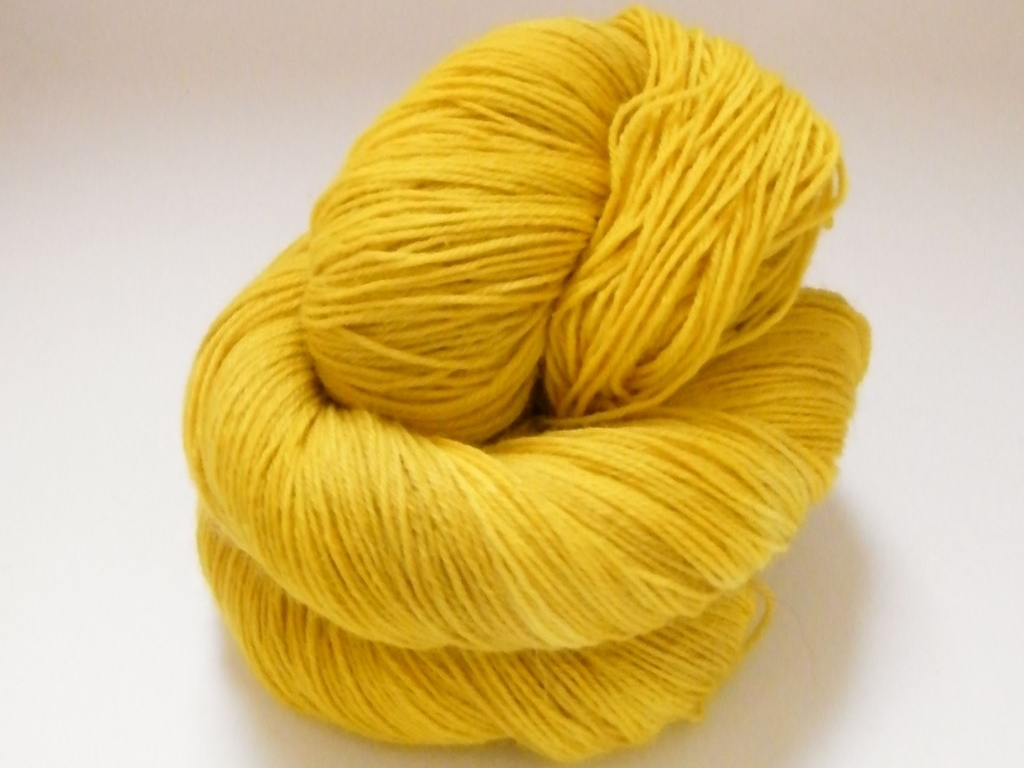Can you tell me what the object in the image is typically used for? Certainly! The object in the image is a skein of yarn, which is typically used for knitting or crocheting a variety of items such as scarves, hats, sweaters, and blankets. It's a versatile material that can be transformed into warm, cozy, and personalized handcrafted goods. What might be the significance of the color for the yarn? The bright yellow color of the yarn can represent cheerfulness and positivity. It's a color often associated with sunshine and can bring a sense of warmth. In craft projects, such a vivid yellow could be used to create statement pieces that stand out or add a pop of color to a more neutral palette. 